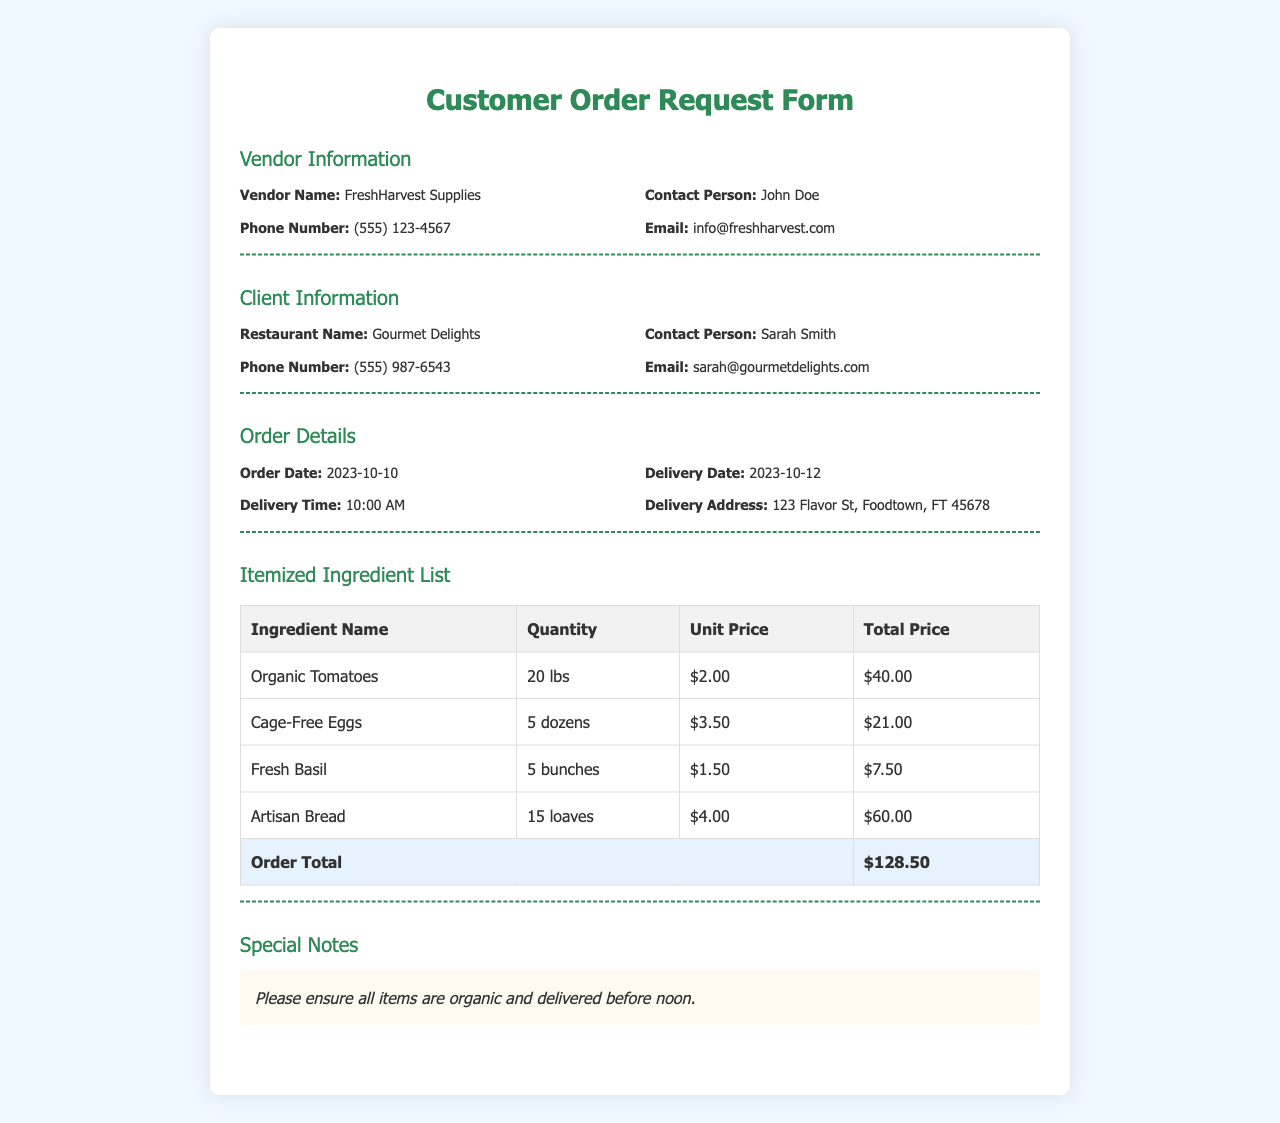what is the name of the vendor? The vendor's name is located in the Vendor Information section of the document.
Answer: FreshHarvest Supplies who is the contact person for the restaurant? The contact person's name for the restaurant is listed in the Client Information section.
Answer: Sarah Smith what is the delivery date? The delivery date is specified in the Order Details section of the document.
Answer: 2023-10-12 how many pounds of organic tomatoes are ordered? The quantity of organic tomatoes is found in the Itemized Ingredient List table.
Answer: 20 lbs what is the total price of the order? The total price is indicated in the Itemized Ingredient List table under the Order Total row.
Answer: $128.50 what special note is mentioned for the order? The special notes section contains additional instructions regarding the order.
Answer: Please ensure all items are organic and delivered before noon how many dozens of cage-free eggs are requested? The quantity of cage-free eggs can be found in the Itemized Ingredient List section.
Answer: 5 dozens what time is the delivery scheduled? The delivery time is mentioned in the Order Details section of the document.
Answer: 10:00 AM what is the email address for the vendor? The vendor's contact email is located in the Vendor Information section.
Answer: info@freshharvest.com 